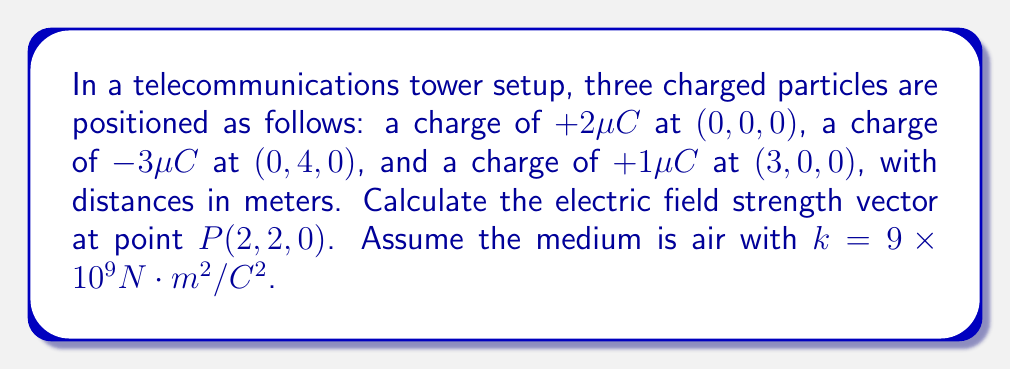Provide a solution to this math problem. 1) We'll use the superposition principle to calculate the total electric field. The electric field due to each charge is given by:

   $$\vec{E} = k\frac{q}{r^2}\hat{r}$$

   where $k$ is Coulomb's constant, $q$ is the charge, $r$ is the distance from the charge to point $P$, and $\hat{r}$ is the unit vector from the charge to $P$.

2) For each charge, calculate $r$ and $\hat{r}$:

   Charge 1 $(+2\mu C)$: $\vec{r_1} = (2,2,0) - (0,0,0) = (2,2,0)$
   $r_1 = \sqrt{2^2 + 2^2} = 2\sqrt{2}$ m
   $\hat{r_1} = \frac{1}{2\sqrt{2}}(2,2,0) = (\frac{1}{\sqrt{2}},\frac{1}{\sqrt{2}},0)$

   Charge 2 $(-3\mu C)$: $\vec{r_2} = (2,2,0) - (0,4,0) = (2,-2,0)$
   $r_2 = \sqrt{2^2 + (-2)^2} = 2\sqrt{2}$ m
   $\hat{r_2} = \frac{1}{2\sqrt{2}}(2,-2,0) = (\frac{1}{\sqrt{2}},-\frac{1}{\sqrt{2}},0)$

   Charge 3 $(+1\mu C)$: $\vec{r_3} = (2,2,0) - (3,0,0) = (-1,2,0)$
   $r_3 = \sqrt{(-1)^2 + 2^2} = \sqrt{5}$ m
   $\hat{r_3} = \frac{1}{\sqrt{5}}(-1,2,0) = (-\frac{1}{\sqrt{5}},\frac{2}{\sqrt{5}},0)$

3) Calculate the electric field for each charge:

   $\vec{E_1} = k\frac{q_1}{r_1^2}\hat{r_1} = 9 \times 10^9 \cdot \frac{2 \times 10^{-6}}{8} (\frac{1}{\sqrt{2}},\frac{1}{\sqrt{2}},0) = 2250(\frac{1}{\sqrt{2}},\frac{1}{\sqrt{2}},0)$ N/C

   $\vec{E_2} = k\frac{q_2}{r_2^2}\hat{r_2} = 9 \times 10^9 \cdot \frac{-3 \times 10^{-6}}{8} (\frac{1}{\sqrt{2}},-\frac{1}{\sqrt{2}},0) = -3375(\frac{1}{\sqrt{2}},-\frac{1}{\sqrt{2}},0)$ N/C

   $\vec{E_3} = k\frac{q_3}{r_3^2}\hat{r_3} = 9 \times 10^9 \cdot \frac{1 \times 10^{-6}}{5} (-\frac{1}{\sqrt{5}},\frac{2}{\sqrt{5}},0) = 1800(-\frac{1}{\sqrt{5}},\frac{2}{\sqrt{5}},0)$ N/C

4) Sum the electric field vectors:

   $\vec{E_{total}} = \vec{E_1} + \vec{E_2} + \vec{E_3}$

   $= (2250\frac{1}{\sqrt{2}}, 2250\frac{1}{\sqrt{2}}, 0) + (-3375\frac{1}{\sqrt{2}}, 3375\frac{1}{\sqrt{2}}, 0) + (-1800\frac{1}{\sqrt{5}}, 3600\frac{1}{\sqrt{5}}, 0)$

5) Simplify:

   $\vec{E_{total}} = (-1125\frac{1}{\sqrt{2}} - 1800\frac{1}{\sqrt{5}}, 5625\frac{1}{\sqrt{2}} + 3600\frac{1}{\sqrt{5}}, 0)$ N/C
Answer: $(-1125\frac{1}{\sqrt{2}} - 1800\frac{1}{\sqrt{5}}, 5625\frac{1}{\sqrt{2}} + 3600\frac{1}{\sqrt{5}}, 0)$ N/C 